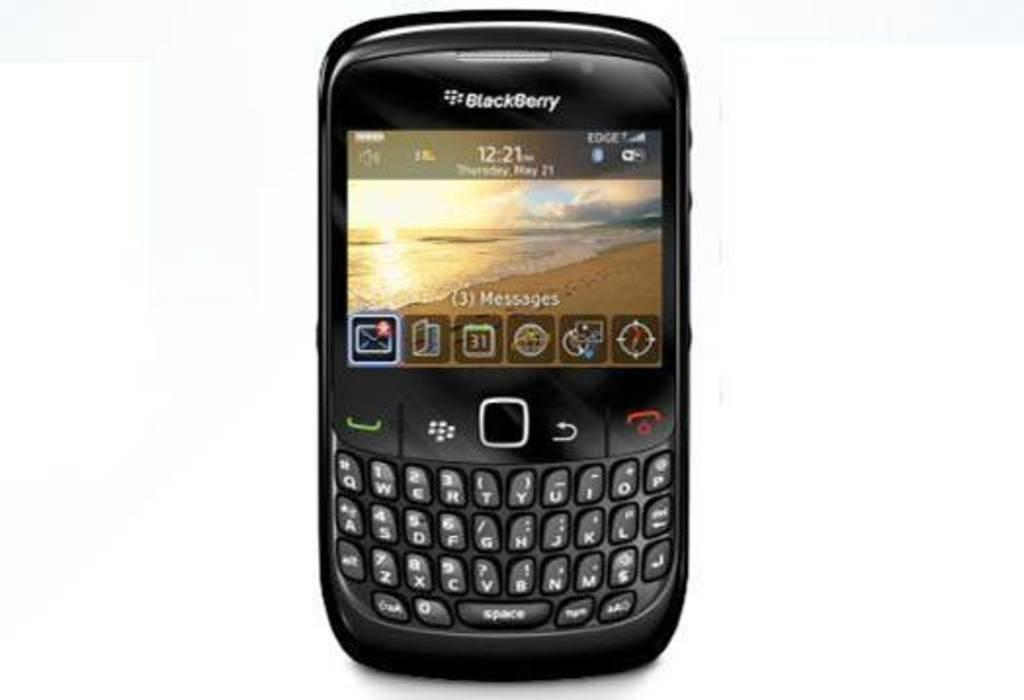<image>
Create a compact narrative representing the image presented. A Blackberry phone shows that there are 3 messages. 